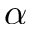Convert formula to latex. <formula><loc_0><loc_0><loc_500><loc_500>\alpha</formula> 